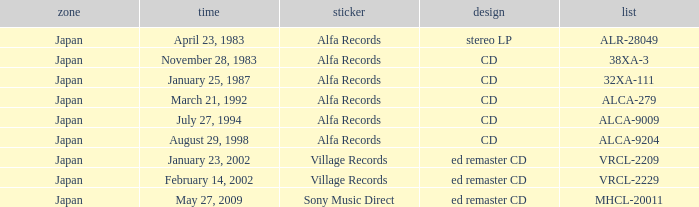Which label is dated February 14, 2002? Village Records. 